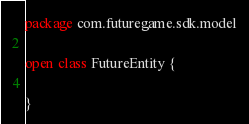Convert code to text. <code><loc_0><loc_0><loc_500><loc_500><_Kotlin_>package com.futuregame.sdk.model

open class FutureEntity {

}</code> 